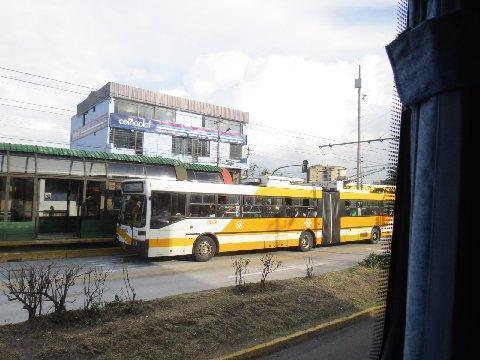How many giraffes are in the picture?
Give a very brief answer. 0. 